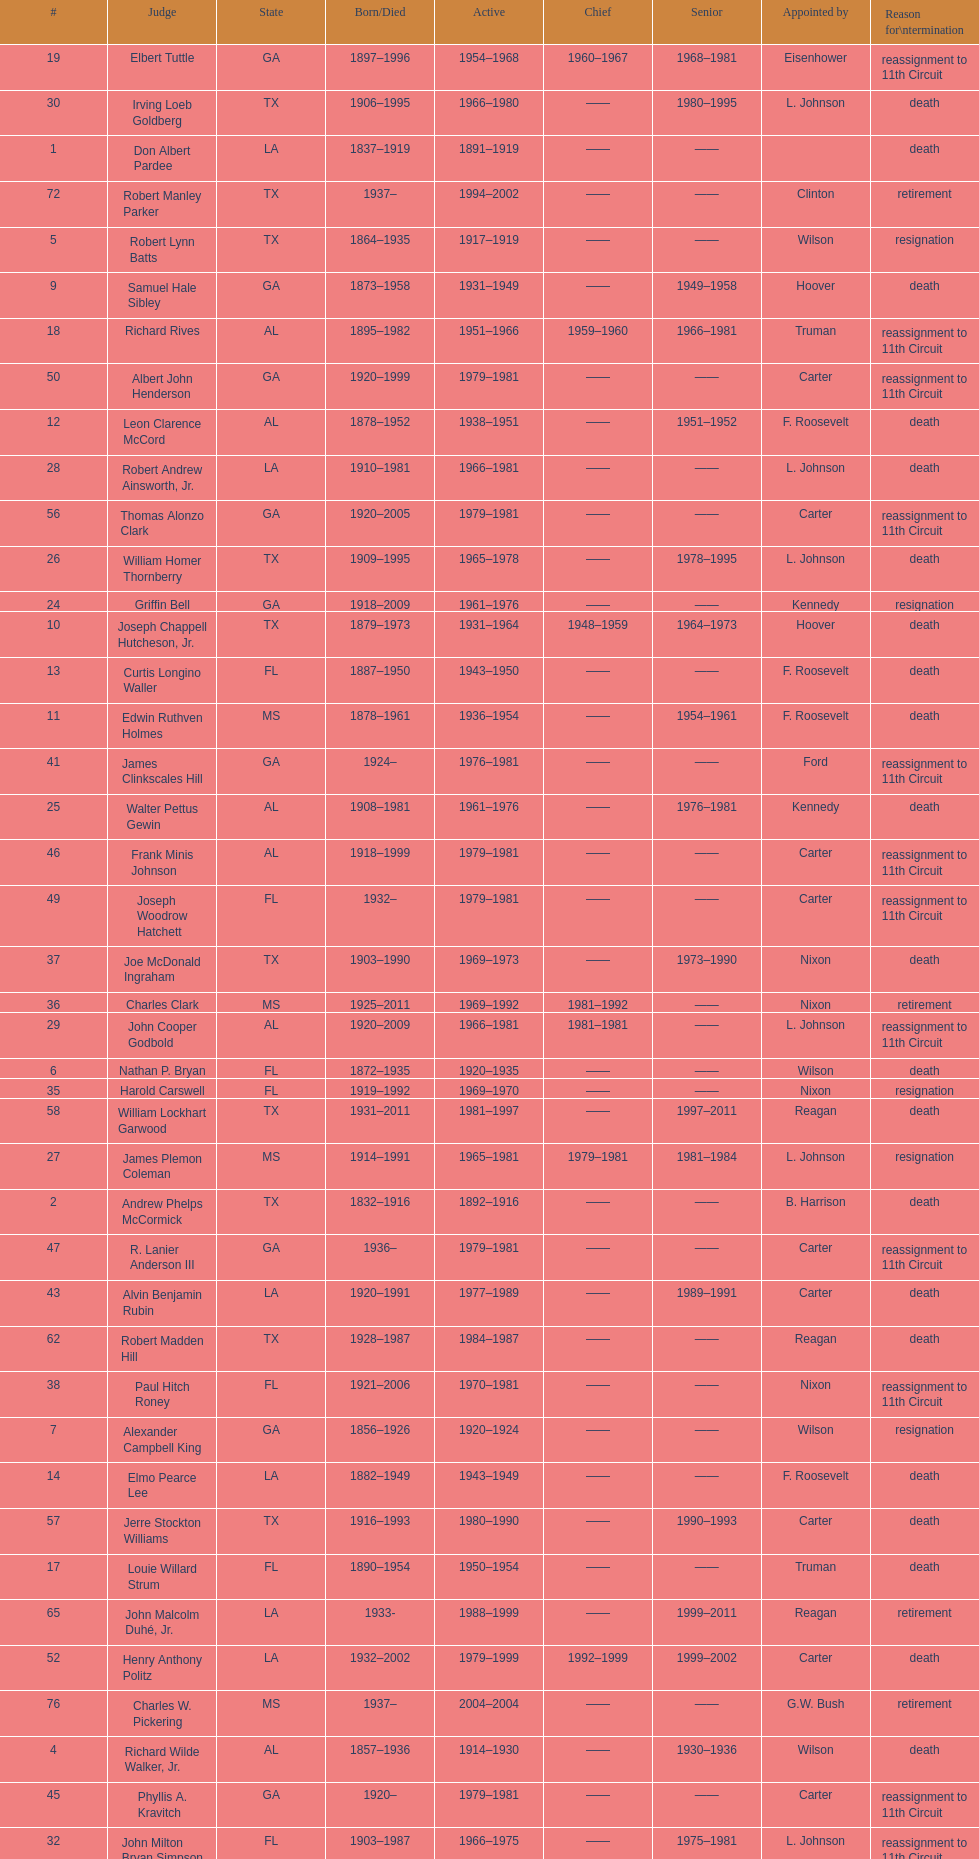Who was the only judge appointed by mckinley? David Davie Shelby. 